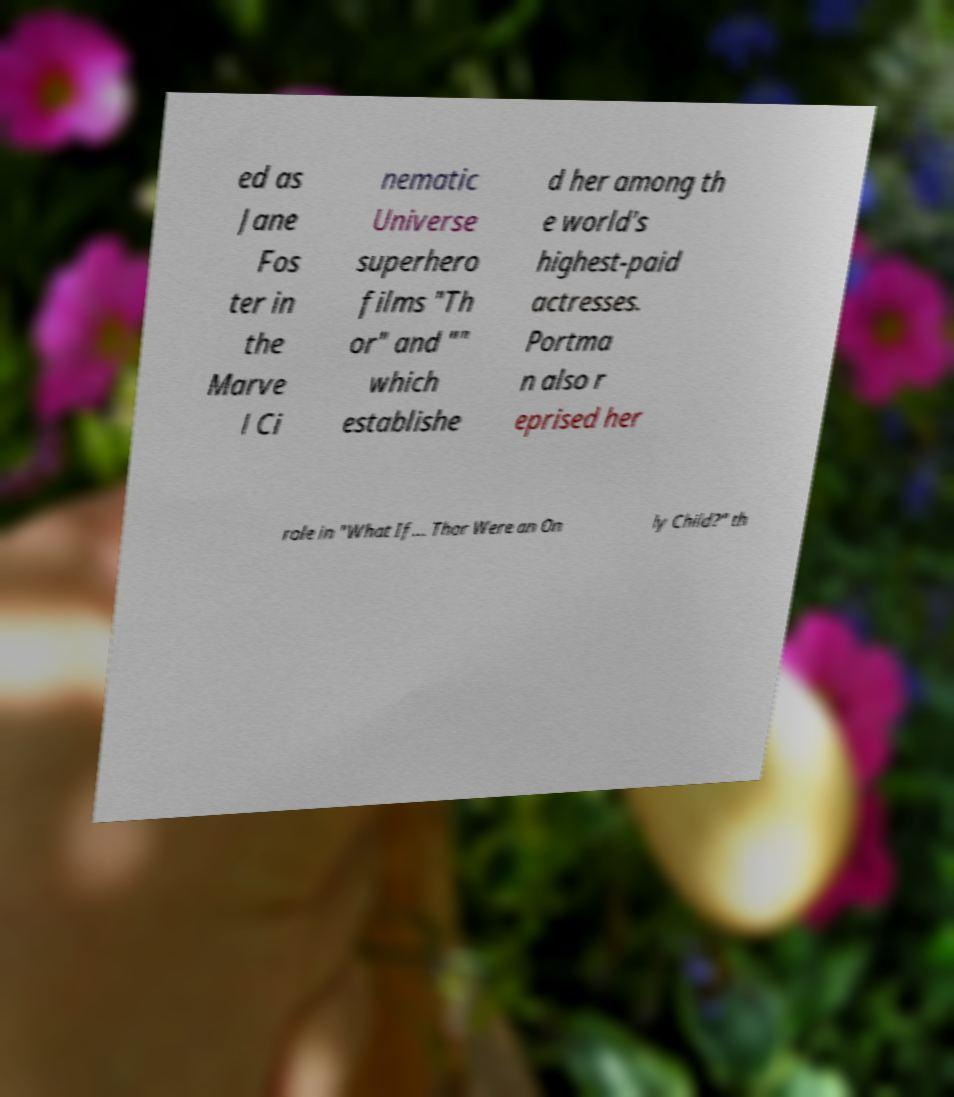Could you extract and type out the text from this image? ed as Jane Fos ter in the Marve l Ci nematic Universe superhero films "Th or" and "" which establishe d her among th e world's highest-paid actresses. Portma n also r eprised her role in "What If... Thor Were an On ly Child?" th 